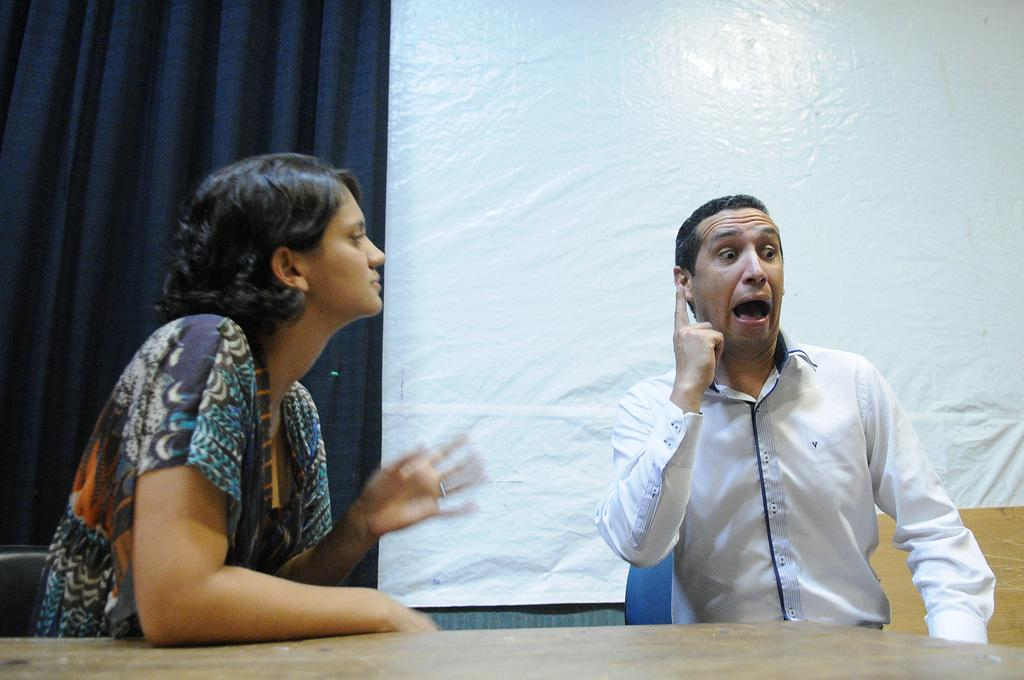How many people are sitting in the image? There are two people sitting in the image. What is located at the bottom of the image? There is a table at the bottom of the image. What can be seen in the background of the image? There is a curtain and a banner in the background of the image. What type of calculator is being used by the people in the image? There is no calculator present in the image; it features two people sitting and a table with a background of a curtain and a banner. 